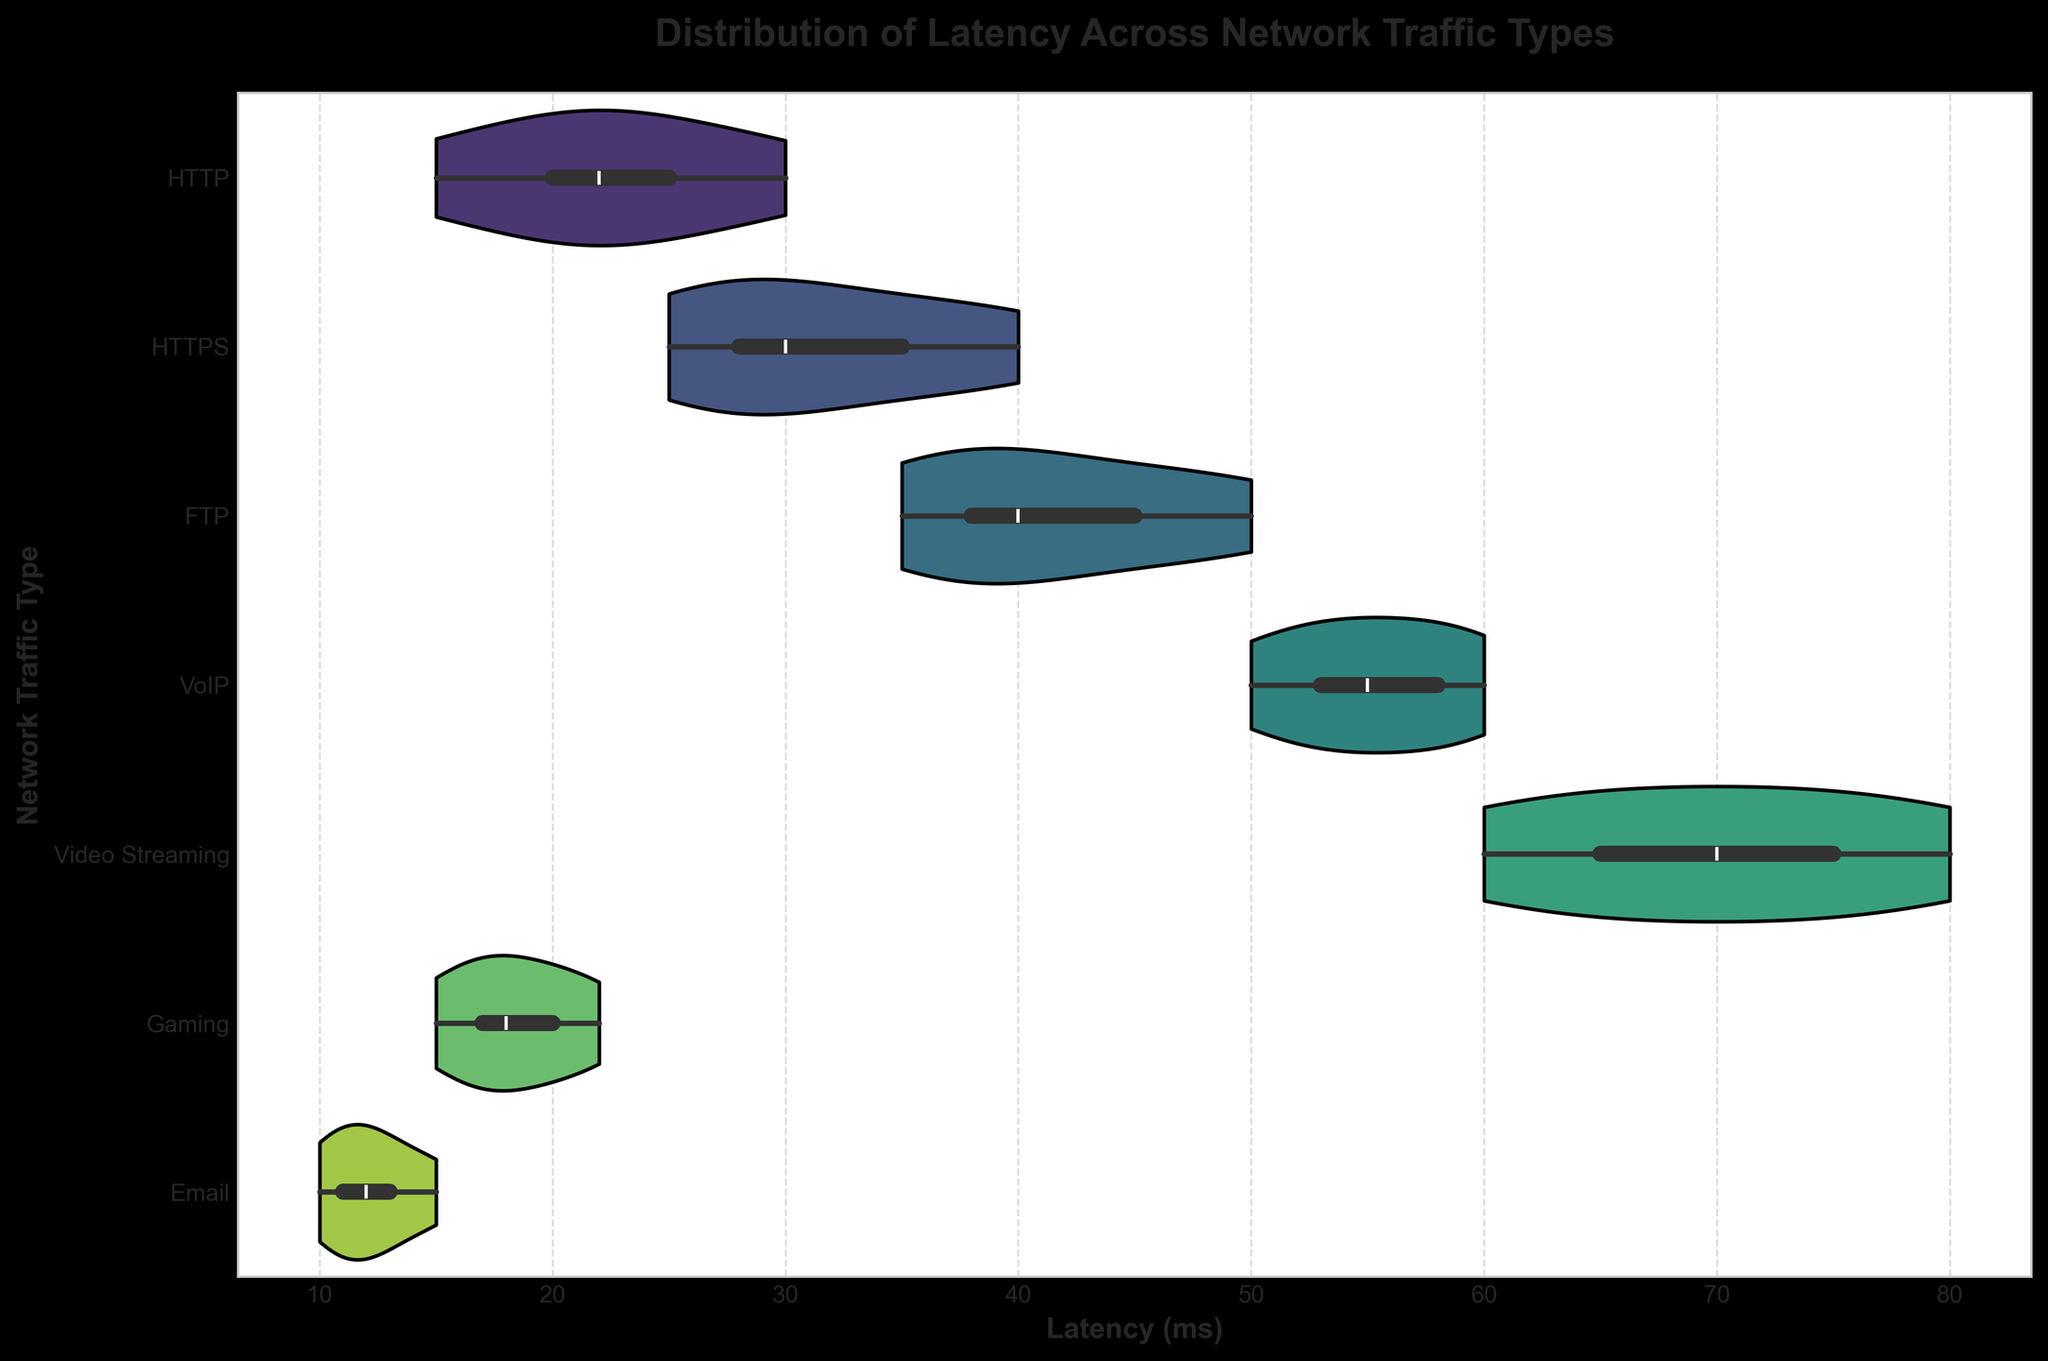What is the title of the plot? The title of the plot is typically written at the top of the figure.
Answer: Distribution of Latency Across Network Traffic Types What are the axis labels for this figure? The axis labels are written next to the respective axes. The x-axis is labeled "Latency (ms)" and the y-axis is labeled "Network Traffic Type".
Answer: Latency (ms) and Network Traffic Type Which network traffic type has the widest distribution of latency? The width of the violin plot indicates the spread of values. The traffic type with the widest distribution will have the broadest plot horizontally.
Answer: Video Streaming What is the range of latency for Email traffic? Look at the horizontal extent of the Email violin plot. The latency ranges from 10 ms to 15 ms.
Answer: 10 ms to 15 ms Which type of network traffic has the lowest overall latency range? The violin plot with the narrowest width along the x-axis indicates the smallest range of latency.
Answer: Email How do the median latencies of HTTP and HTTPS compare? The median is generally represented by a white dot or a line inside the violin plot. Compare the positions of these medians within the HTTP and HTTPS violins.
Answer: HTTPS has a higher median latency than HTTP What can you infer about the distribution shape of the FTP latency? The shape of the violin plot can indicate symmetry, skewness, or multimodality. Examine the FTP plot for these characteristics.
Answer: The FTP latency distribution appears to be moderately symmetric and possibly slightly skewed to the right Which type of network traffic has the highest maximum latency? The highest value is indicated by the farthest right edge of any violin plot.
Answer: Video Streaming Are there any network traffic types with similar latency distributions? Compare the shapes and ranges of the violin plots to identify any similar distributions.
Answer: HTTP and Gaming have somewhat similar latency distributions What appears to be the average latency range for VoIP traffic? The average can be inferred from the most substantial part of the violin plot horizontally.
Answer: Approximately 50 ms to 60 ms 